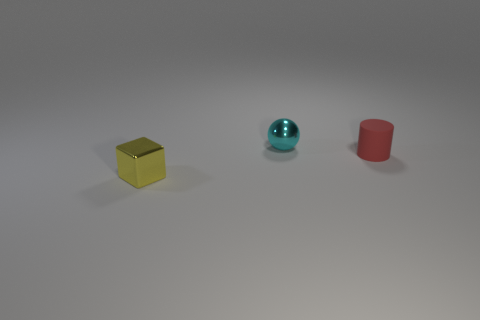What number of small red matte things are the same shape as the yellow thing?
Offer a terse response. 0. How many things are either tiny shiny balls or tiny things that are to the left of the sphere?
Provide a short and direct response. 2. Do the sphere and the metallic thing that is on the left side of the ball have the same color?
Give a very brief answer. No. How big is the object that is to the right of the block and in front of the sphere?
Offer a terse response. Small. Are there any small metal spheres in front of the cyan object?
Your answer should be compact. No. Are there any small metallic balls that are in front of the tiny object in front of the tiny red rubber cylinder?
Give a very brief answer. No. Is the number of blocks in front of the red rubber cylinder the same as the number of small cyan objects that are in front of the tiny cyan sphere?
Make the answer very short. No. What is the color of the tiny object that is made of the same material as the tiny cyan ball?
Ensure brevity in your answer.  Yellow. Are there any tiny blue things that have the same material as the small yellow object?
Offer a terse response. No. How many objects are either small purple blocks or spheres?
Your response must be concise. 1. 